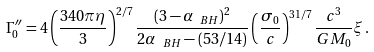Convert formula to latex. <formula><loc_0><loc_0><loc_500><loc_500>\Gamma ^ { \prime \prime } _ { 0 } = 4 \left ( \frac { 3 4 0 \pi \eta } { 3 } \right ) ^ { 2 / 7 } \frac { ( 3 - \alpha _ { \ B H } ) ^ { 2 } } { 2 \alpha _ { \ B H } - ( 5 3 / 1 4 ) } \left ( \frac { \sigma _ { 0 } } { c } \right ) ^ { 3 1 / 7 } \frac { c ^ { 3 } } { G M _ { 0 } } \xi \, .</formula> 